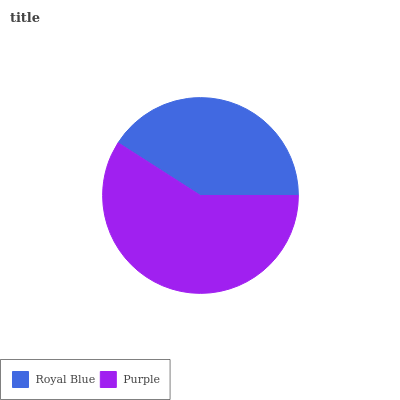Is Royal Blue the minimum?
Answer yes or no. Yes. Is Purple the maximum?
Answer yes or no. Yes. Is Purple the minimum?
Answer yes or no. No. Is Purple greater than Royal Blue?
Answer yes or no. Yes. Is Royal Blue less than Purple?
Answer yes or no. Yes. Is Royal Blue greater than Purple?
Answer yes or no. No. Is Purple less than Royal Blue?
Answer yes or no. No. Is Purple the high median?
Answer yes or no. Yes. Is Royal Blue the low median?
Answer yes or no. Yes. Is Royal Blue the high median?
Answer yes or no. No. Is Purple the low median?
Answer yes or no. No. 